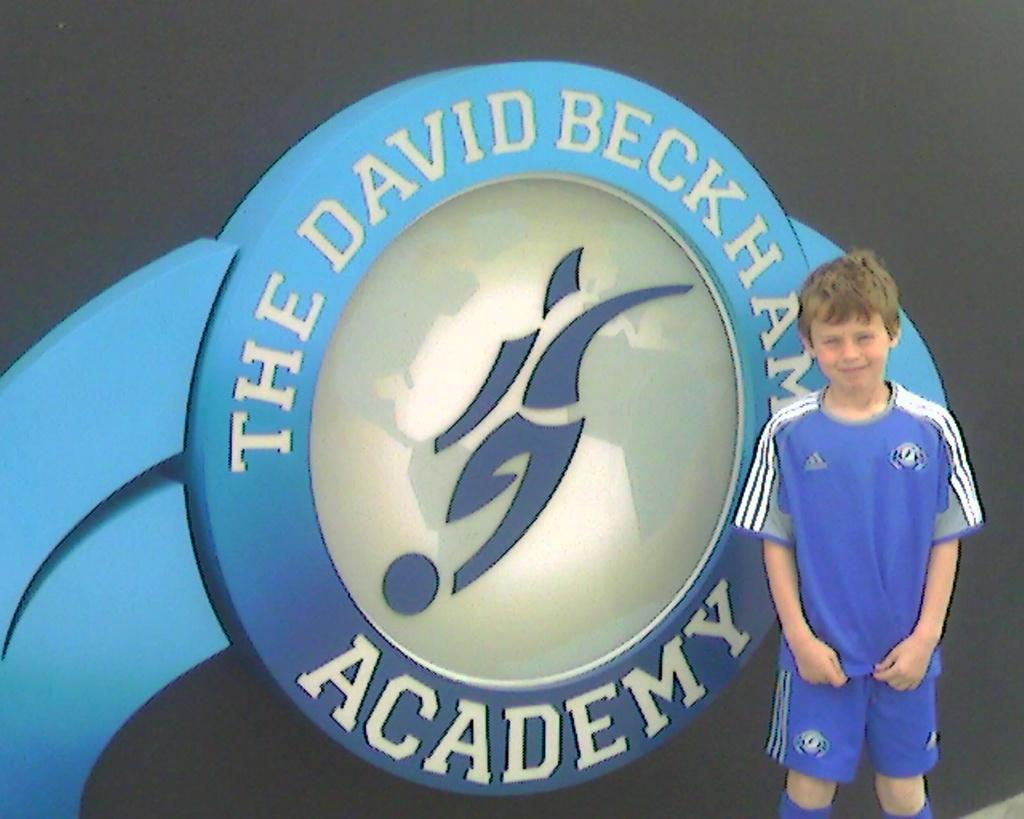Provide a one-sentence caption for the provided image. Young boy standing in front of the david beckham academy sign. 